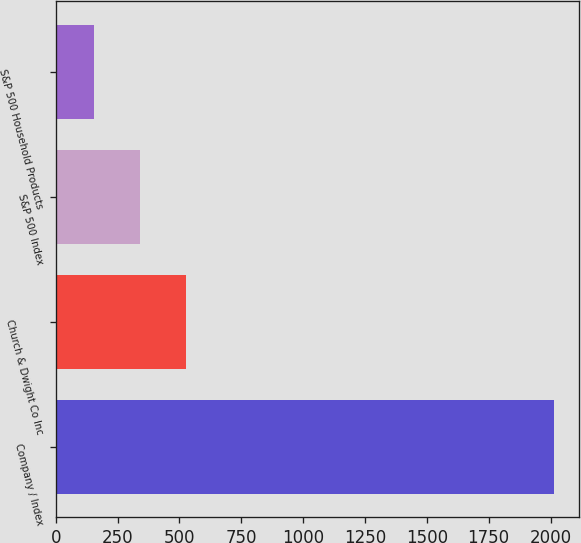Convert chart. <chart><loc_0><loc_0><loc_500><loc_500><bar_chart><fcel>Company / Index<fcel>Church & Dwight Co Inc<fcel>S&P 500 Index<fcel>S&P 500 Household Products<nl><fcel>2016<fcel>528.03<fcel>342.03<fcel>156.03<nl></chart> 